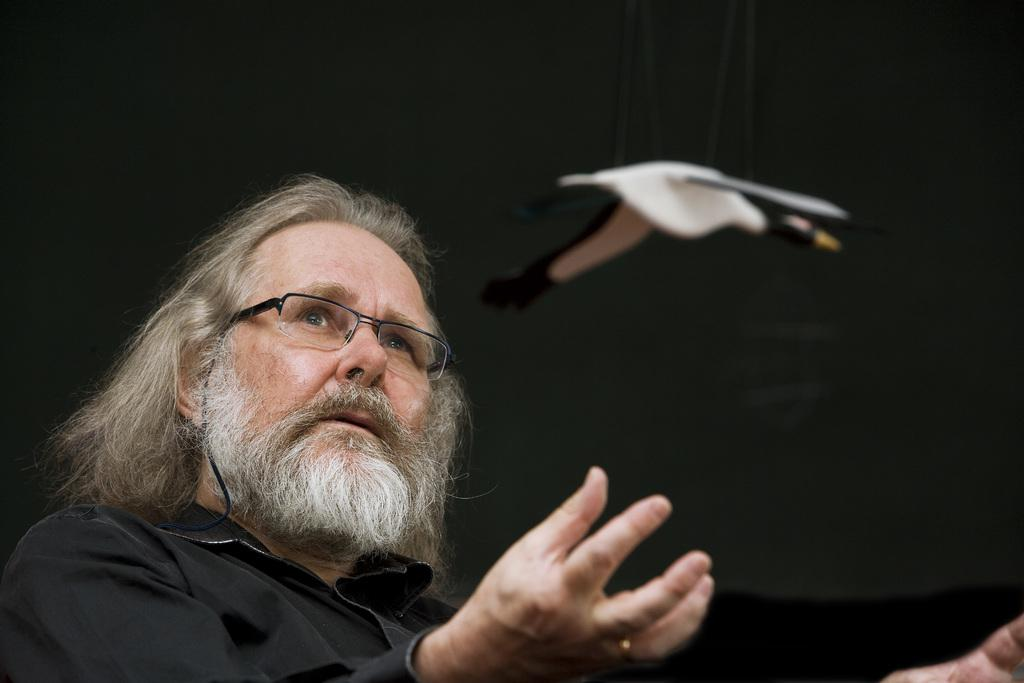What is the main subject of the image? There is a person in the image. What is the person wearing? The person is wearing a black shirt and spectacles. What object can be seen in the image besides the person? There is a toy bird in the image. What are the colors of the toy bird? The toy bird is black and white in color. What is the toy bird doing in the image? The toy bird is in the air. What is the color of the background in the image? The background of the image is black in color. How many mice are playing with the button in the image? There are no mice or buttons present in the image. What type of brother is shown in the image? There is no brother depicted in the image; it features a person and a toy bird. 